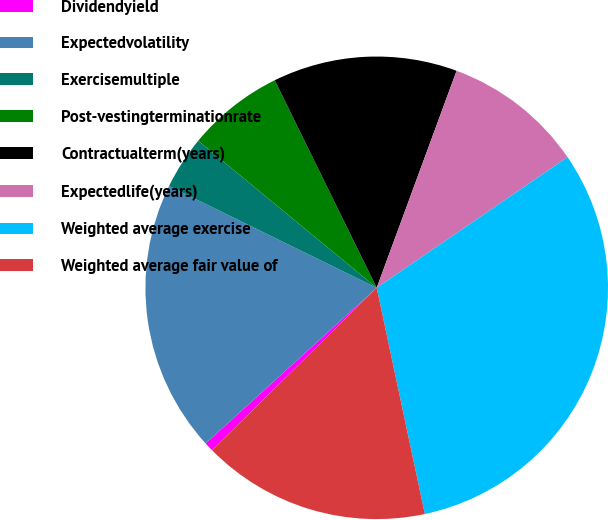Convert chart. <chart><loc_0><loc_0><loc_500><loc_500><pie_chart><fcel>Dividendyield<fcel>Expectedvolatility<fcel>Exercisemultiple<fcel>Post-vestingterminationrate<fcel>Contractualterm(years)<fcel>Expectedlife(years)<fcel>Weighted average exercise<fcel>Weighted average fair value of<nl><fcel>0.65%<fcel>19.0%<fcel>3.71%<fcel>6.77%<fcel>12.88%<fcel>9.83%<fcel>31.22%<fcel>15.94%<nl></chart> 